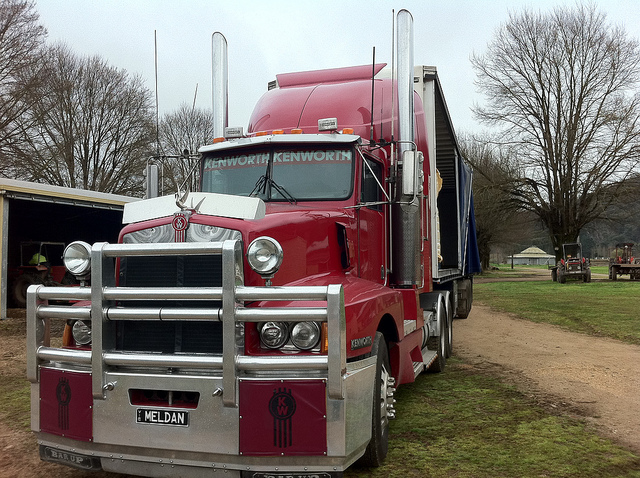Please identify all text content in this image. KENWORTH KENWORTH MELDAN KENWORTH 